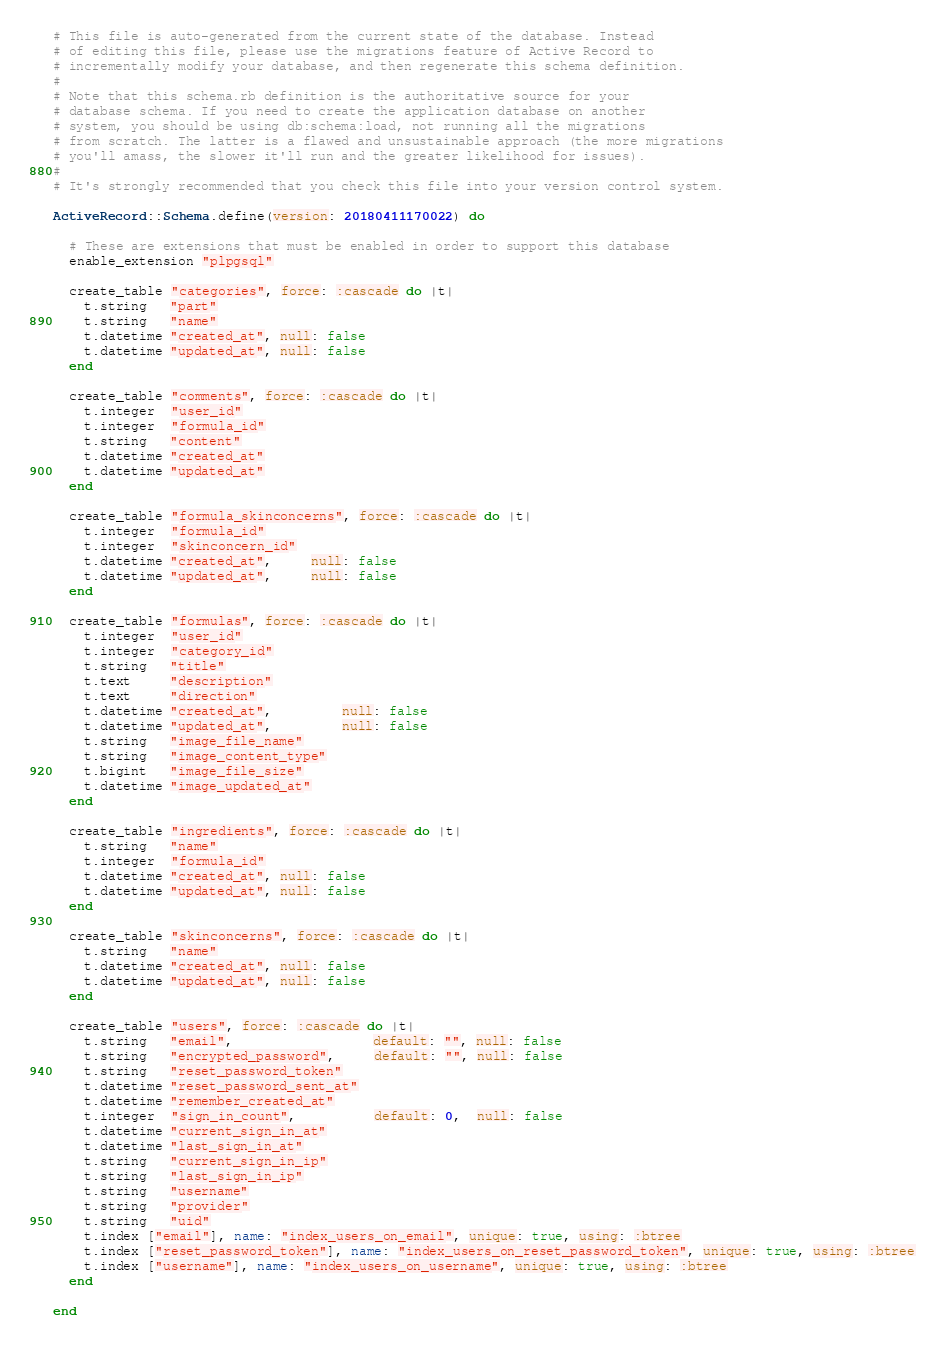<code> <loc_0><loc_0><loc_500><loc_500><_Ruby_># This file is auto-generated from the current state of the database. Instead
# of editing this file, please use the migrations feature of Active Record to
# incrementally modify your database, and then regenerate this schema definition.
#
# Note that this schema.rb definition is the authoritative source for your
# database schema. If you need to create the application database on another
# system, you should be using db:schema:load, not running all the migrations
# from scratch. The latter is a flawed and unsustainable approach (the more migrations
# you'll amass, the slower it'll run and the greater likelihood for issues).
#
# It's strongly recommended that you check this file into your version control system.

ActiveRecord::Schema.define(version: 20180411170022) do

  # These are extensions that must be enabled in order to support this database
  enable_extension "plpgsql"

  create_table "categories", force: :cascade do |t|
    t.string   "part"
    t.string   "name"
    t.datetime "created_at", null: false
    t.datetime "updated_at", null: false
  end

  create_table "comments", force: :cascade do |t|
    t.integer  "user_id"
    t.integer  "formula_id"
    t.string   "content"
    t.datetime "created_at"
    t.datetime "updated_at"
  end

  create_table "formula_skinconcerns", force: :cascade do |t|
    t.integer  "formula_id"
    t.integer  "skinconcern_id"
    t.datetime "created_at",     null: false
    t.datetime "updated_at",     null: false
  end

  create_table "formulas", force: :cascade do |t|
    t.integer  "user_id"
    t.integer  "category_id"
    t.string   "title"
    t.text     "description"
    t.text     "direction"
    t.datetime "created_at",         null: false
    t.datetime "updated_at",         null: false
    t.string   "image_file_name"
    t.string   "image_content_type"
    t.bigint   "image_file_size"
    t.datetime "image_updated_at"
  end

  create_table "ingredients", force: :cascade do |t|
    t.string   "name"
    t.integer  "formula_id"
    t.datetime "created_at", null: false
    t.datetime "updated_at", null: false
  end

  create_table "skinconcerns", force: :cascade do |t|
    t.string   "name"
    t.datetime "created_at", null: false
    t.datetime "updated_at", null: false
  end

  create_table "users", force: :cascade do |t|
    t.string   "email",                  default: "", null: false
    t.string   "encrypted_password",     default: "", null: false
    t.string   "reset_password_token"
    t.datetime "reset_password_sent_at"
    t.datetime "remember_created_at"
    t.integer  "sign_in_count",          default: 0,  null: false
    t.datetime "current_sign_in_at"
    t.datetime "last_sign_in_at"
    t.string   "current_sign_in_ip"
    t.string   "last_sign_in_ip"
    t.string   "username"
    t.string   "provider"
    t.string   "uid"
    t.index ["email"], name: "index_users_on_email", unique: true, using: :btree
    t.index ["reset_password_token"], name: "index_users_on_reset_password_token", unique: true, using: :btree
    t.index ["username"], name: "index_users_on_username", unique: true, using: :btree
  end

end
</code> 